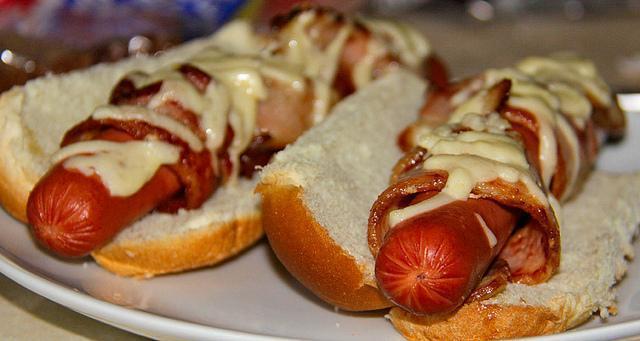How many hot dogs are there?
Give a very brief answer. 2. 